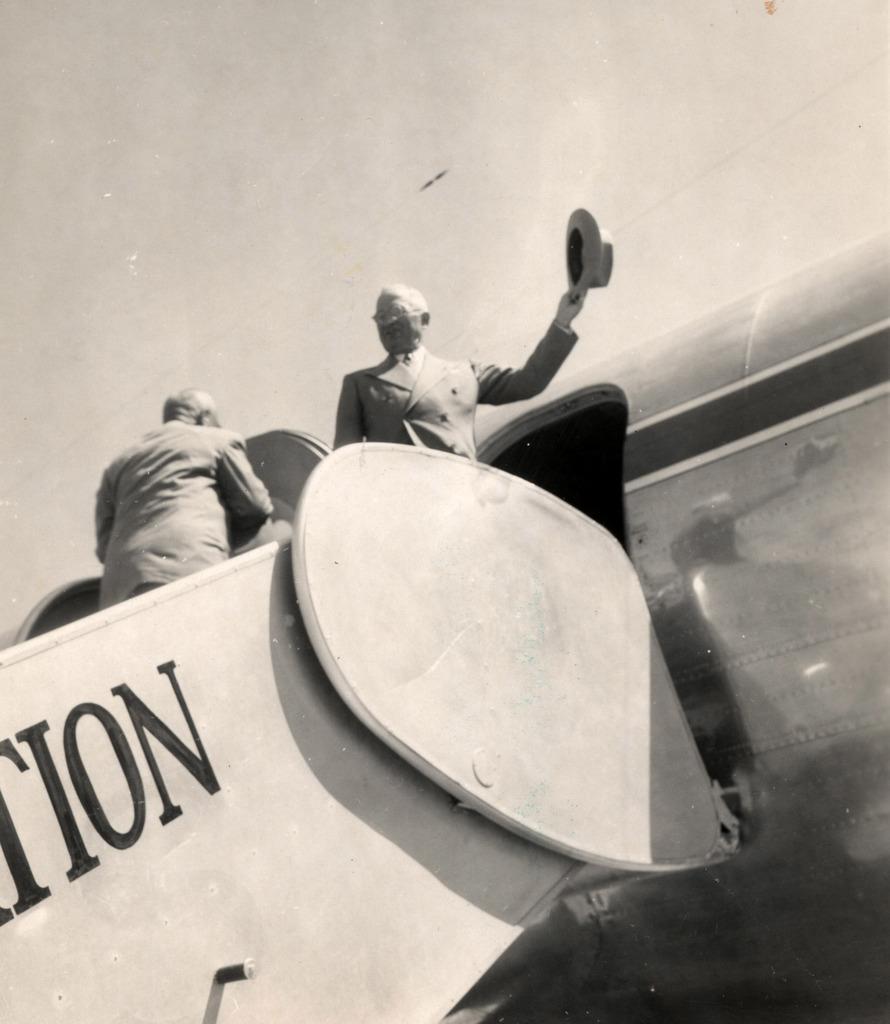Can you describe this image briefly? In the image in the center, we can see two persons are standing on the airplane steps. And the right side person is holding a hat. And we can see something written on the plane. 